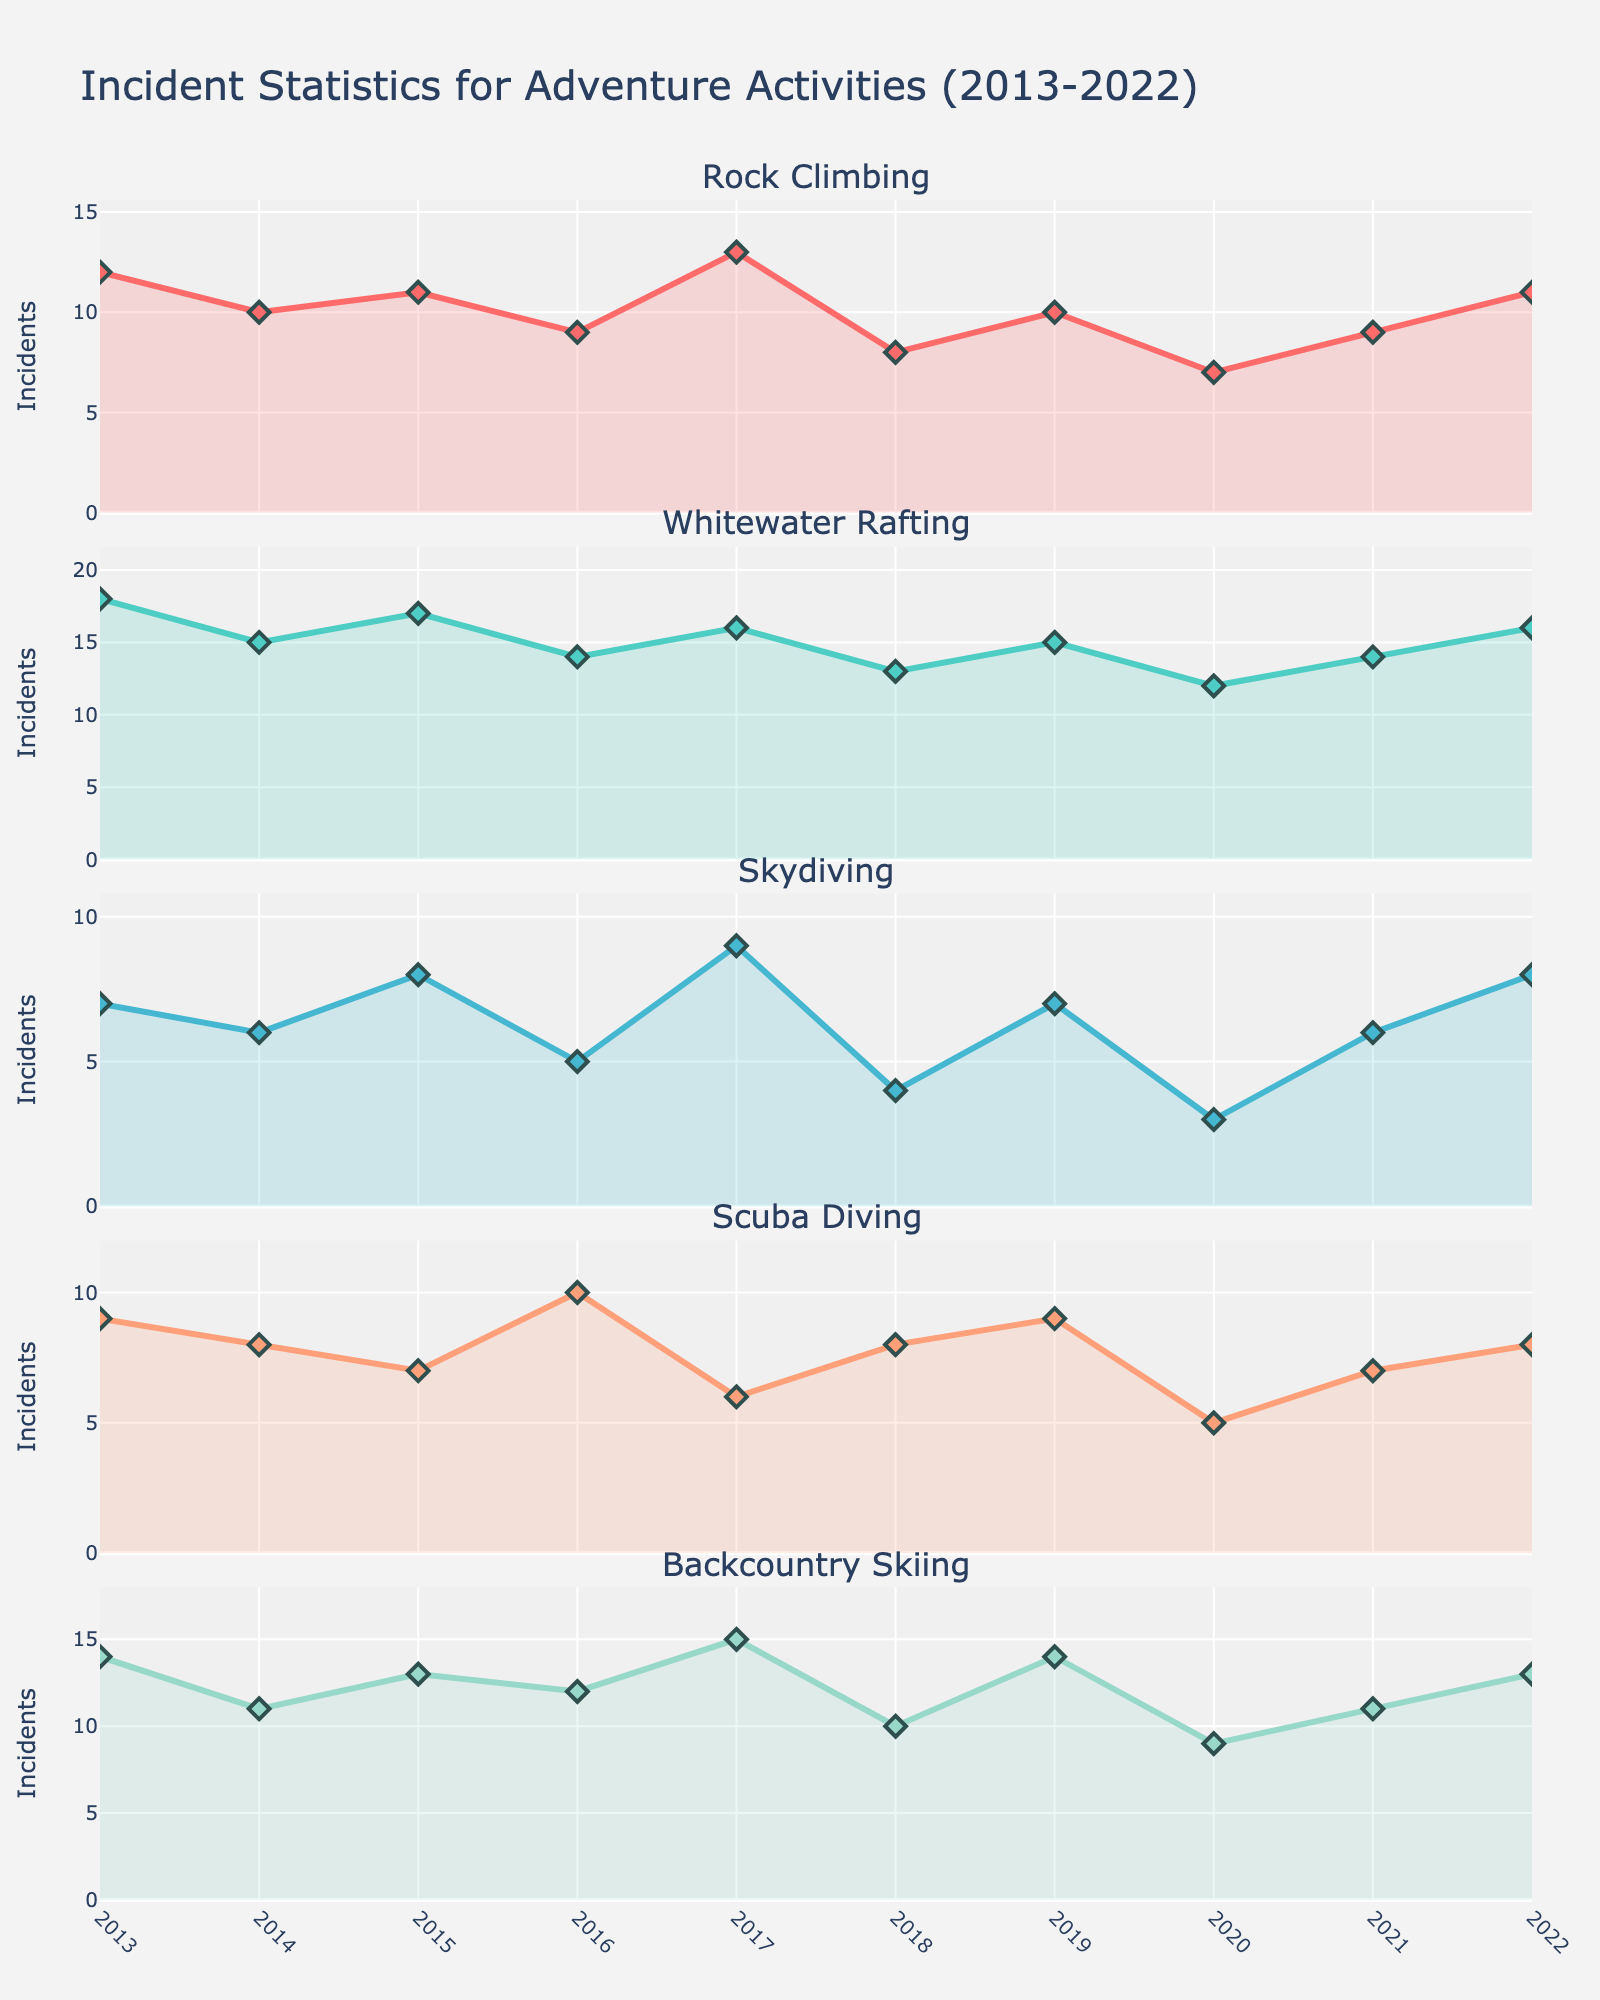What's the title of the figure? The title is located at the top center of the figure. It provides an overview of what the figure represents.
Answer: Incident Statistics for Adventure Activities (2013-2022) How many years are displayed on the x-axis? To answer this, count the tick marks along the x-axis. Each tick represents a specific year.
Answer: 10 Which year had the highest number of rock climbing incidents? Look at the Rock Climbing subplot and find the peak point on its line. Check the corresponding year on the x-axis.
Answer: 2017 What is the average number of skydiving incidents over the decade? Add all the skydiving incident values from 2013 to 2022 and divide by the number of years (10). (7 + 6 + 8 + 5 + 9 + 4 + 7 + 3 + 6 + 8) / 10 = 63 / 10.
Answer: 6.3 In which year did Scuba Diving incidents equal their highest value, and what was that value? Look at the highest point of the Scuba Diving line, then find the corresponding year on the x-axis and read the y-axis value.
Answer: 2016, 10 Compare the number of whitewater rafting incidents in 2014 and 2022. Which year had more incidents and by how much? Look at the values of whitewater rafting incidents in 2014 and 2022 then subtract the smaller value from the larger one to determine the difference.
Answer: 2022, by 1 incident Which adventure activity had the fewest incident counts in 2020, and what was the count? Identify the subplot with the lowest peak in the year 2020.
Answer: Skydiving, 3 What's the total number of incidents for backcountry skiing over the entire period? Add up all the incidents for backcountry skiing from 2013 to 2022. 14 + 11 + 13 + 12 + 15 + 10 + 14 + 9 + 11 + 13.
Answer: 122 How did the number of incidents in whitewater rafting change between 2016 and 2019? Subtract the number of incidents in 2016 from the number of incidents in 2019 to find the change.
Answer: Increased by 1 Which year had the lowest number of incidents across all adventure activities combined? Sum the incidents for all activities for each year and identify the year with the lowest total.
Answer: 2020 